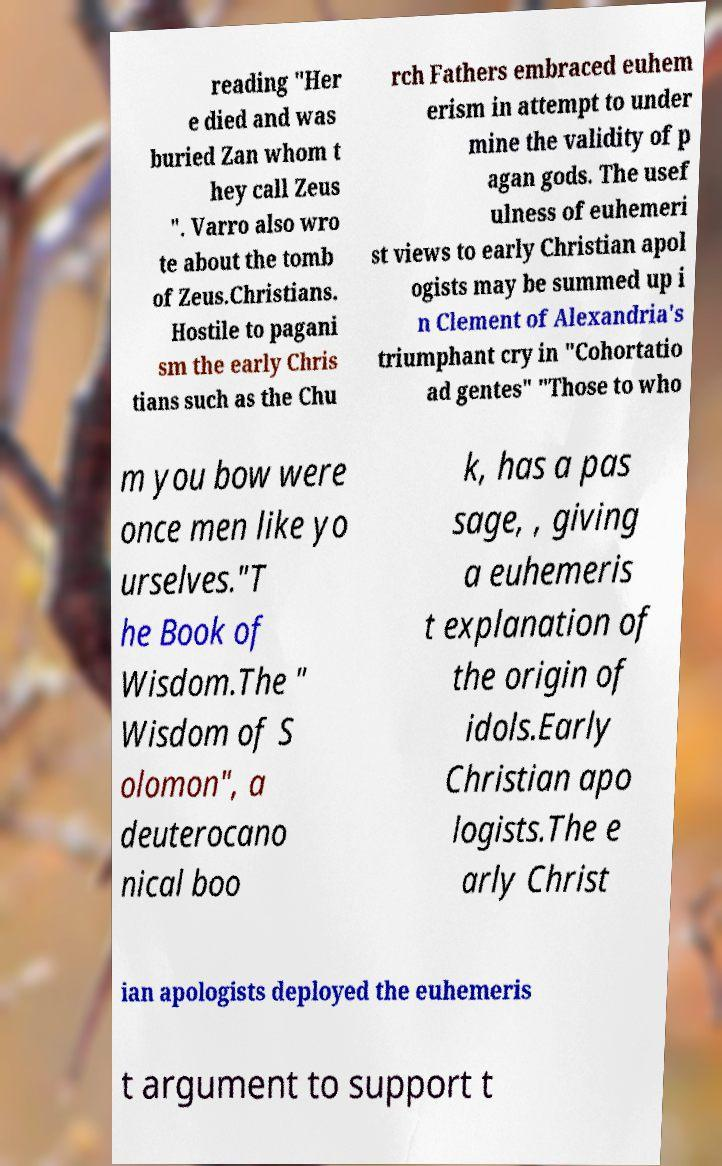Can you read and provide the text displayed in the image?This photo seems to have some interesting text. Can you extract and type it out for me? reading "Her e died and was buried Zan whom t hey call Zeus ". Varro also wro te about the tomb of Zeus.Christians. Hostile to pagani sm the early Chris tians such as the Chu rch Fathers embraced euhem erism in attempt to under mine the validity of p agan gods. The usef ulness of euhemeri st views to early Christian apol ogists may be summed up i n Clement of Alexandria's triumphant cry in "Cohortatio ad gentes" "Those to who m you bow were once men like yo urselves."T he Book of Wisdom.The " Wisdom of S olomon", a deuterocano nical boo k, has a pas sage, , giving a euhemeris t explanation of the origin of idols.Early Christian apo logists.The e arly Christ ian apologists deployed the euhemeris t argument to support t 